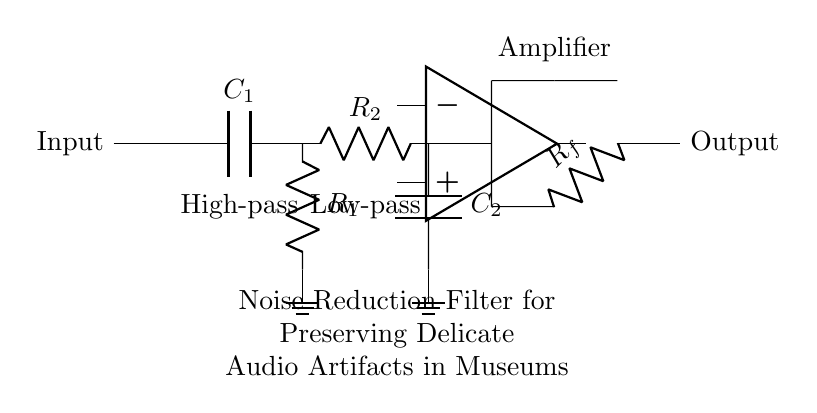What type of filter is represented in the circuit? The circuit combines both high-pass and low-pass filtering stages, indicating it's a noise reduction filter.
Answer: Noise reduction filter What is the function of capacitor C1? Capacitor C1 is part of the high-pass filter stage, allowing higher frequency signals to pass while blocking lower frequency signals, thus aiding in noise reduction.
Answer: High-pass filter How many resistors are in this circuit? The circuit includes two resistors, R1 and R2, one for each filter stage (high-pass and low-pass).
Answer: Two What is the role of the amplifier in this circuit? The amplifier increases the strength of the audio signal after it has been filtered to improve overall output without introducing additional noise.
Answer: Signal amplification What does the low-pass filter stage do? The low-pass filter stage allows low-frequency signals to pass and attenuates high-frequency noise, critical for preserving delicate audio artifacts.
Answer: Attenuation of high frequencies How do the components work together in this circuit? The combination of high-pass and low-pass filters effectively filters out unwanted noise while maintaining the integrity of crucial audio signals, assisted by the amplifier's gain.
Answer: Frequency filtering and amplification 